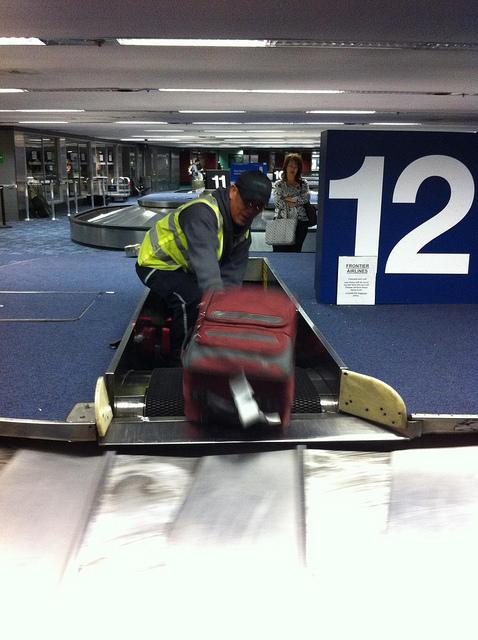Who employs the man in the yellow vest? Please explain your reasoning. airport. The area shows a belt with luggage. 